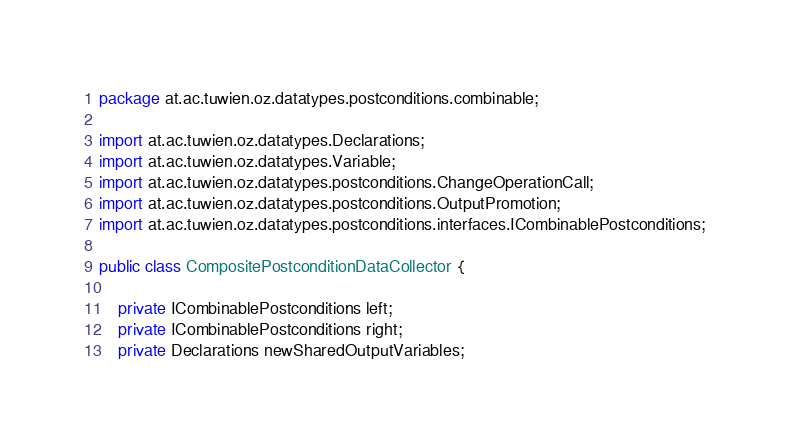Convert code to text. <code><loc_0><loc_0><loc_500><loc_500><_Java_>package at.ac.tuwien.oz.datatypes.postconditions.combinable;

import at.ac.tuwien.oz.datatypes.Declarations;
import at.ac.tuwien.oz.datatypes.Variable;
import at.ac.tuwien.oz.datatypes.postconditions.ChangeOperationCall;
import at.ac.tuwien.oz.datatypes.postconditions.OutputPromotion;
import at.ac.tuwien.oz.datatypes.postconditions.interfaces.ICombinablePostconditions;

public class CompositePostconditionDataCollector {

	private ICombinablePostconditions left;
	private ICombinablePostconditions right;
	private Declarations newSharedOutputVariables;</code> 